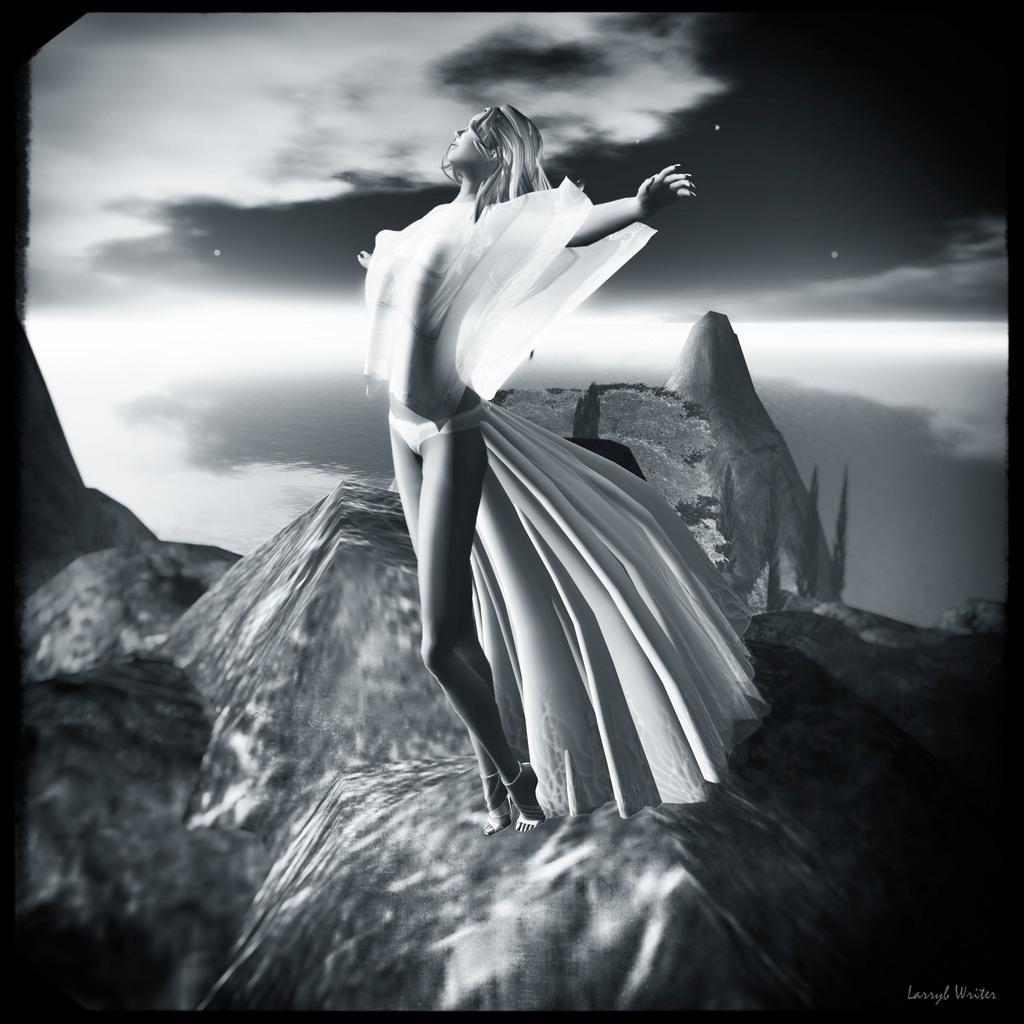Can you describe this image briefly? This is an animated image. In this image we can see a woman standing on a rock. In the background of the image there is sky. 